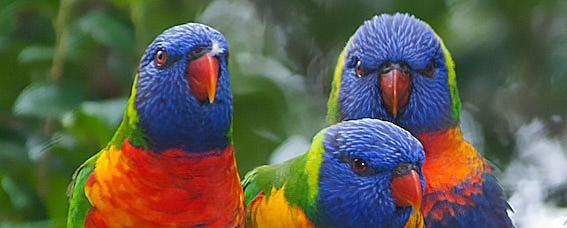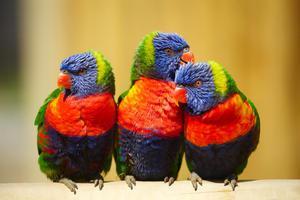The first image is the image on the left, the second image is the image on the right. For the images shown, is this caption "There is exactly three parrots in the right image." true? Answer yes or no. Yes. The first image is the image on the left, the second image is the image on the right. Analyze the images presented: Is the assertion "A total of six birds are shown, and at least some are perching on light-colored, smooth wood." valid? Answer yes or no. Yes. 